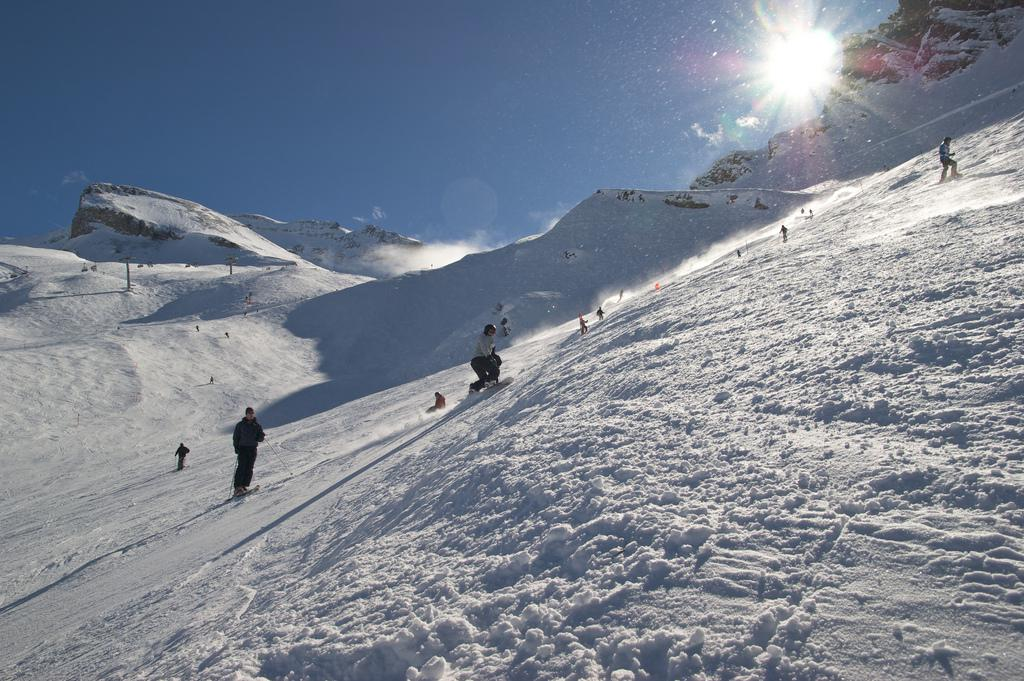Question: where is the photo taken?
Choices:
A. Mountain side.
B. Ski resort.
C. Tennessee.
D. Colorado.
Answer with the letter. Answer: A Question: what are the people doing?
Choices:
A. Listening to a speaker.
B. Skiing and snowboarding.
C. Flying kites.
D. Emjoying the museum.
Answer with the letter. Answer: B Question: what takes place outdoors?
Choices:
A. Kids playing.
B. Cars driving on a road.
C. The scene.
D. Lawn mowing.
Answer with the letter. Answer: C Question: what are they doing?
Choices:
A. Playing.
B. Competing.
C. Running.
D. Skiing / snowboarding.
Answer with the letter. Answer: D Question: what is jutting from the mountain?
Choices:
A. Trees.
B. Rocks.
C. Mining equipment.
D. Cliffs.
Answer with the letter. Answer: B Question: where are these people?
Choices:
A. On a beach.
B. An a hill.
C. On  a plain.
D. On a mountain.
Answer with the letter. Answer: D Question: what season is it?
Choices:
A. Spring.
B. Summer.
C. Winter.
D. Fall.
Answer with the letter. Answer: C Question: why are they wearing winter clothes?
Choices:
A. Because its cold.
B. Because its snowing.
C. Because its freezing.
D. Because its chilly.
Answer with the letter. Answer: A Question: what is on the ground?
Choices:
A. Dust.
B. Snow.
C. Sand.
D. Soil.
Answer with the letter. Answer: B Question: where is the sun in this picture?
Choices:
A. Top Left.
B. Right.
C. Left.
D. Top right.
Answer with the letter. Answer: D Question: where is the photo taken?
Choices:
A. On a ski slope.
B. At the lake.
C. On the beach.
D. In a car.
Answer with the letter. Answer: A Question: where are shadows cast?
Choices:
A. On the floor.
B. On the street.
C. On the wall.
D. Onto the snow.
Answer with the letter. Answer: D Question: what color is the sky?
Choices:
A. Turquoise.
B. Cobalt.
C. Grey.
D. Very blue.
Answer with the letter. Answer: D Question: what are the people doing?
Choices:
A. Running.
B. Skiing.
C. Playing.
D. Swimming.
Answer with the letter. Answer: B Question: how is the weather?
Choices:
A. Clear and cold.
B. Snowy.
C. Cloudy.
D. Hot and dry.
Answer with the letter. Answer: A Question: what is halfway up the hill?
Choices:
A. The waterfall.
B. An orange flag.
C. The telephone pole.
D. The shack.
Answer with the letter. Answer: B Question: what is on the ground?
Choices:
A. Leaves.
B. Grass.
C. Dirt.
D. Snow.
Answer with the letter. Answer: D Question: what is in the distance?
Choices:
A. Houses.
B. Buildings.
C. Pastures.
D. Mountains.
Answer with the letter. Answer: D Question: what is on the ground?
Choices:
A. Dew.
B. Leaves.
C. Snow.
D. Hail.
Answer with the letter. Answer: C Question: who is skiing?
Choices:
A. The skiers.
B. The children.
C. The dog.
D. The snowboarders.
Answer with the letter. Answer: A 